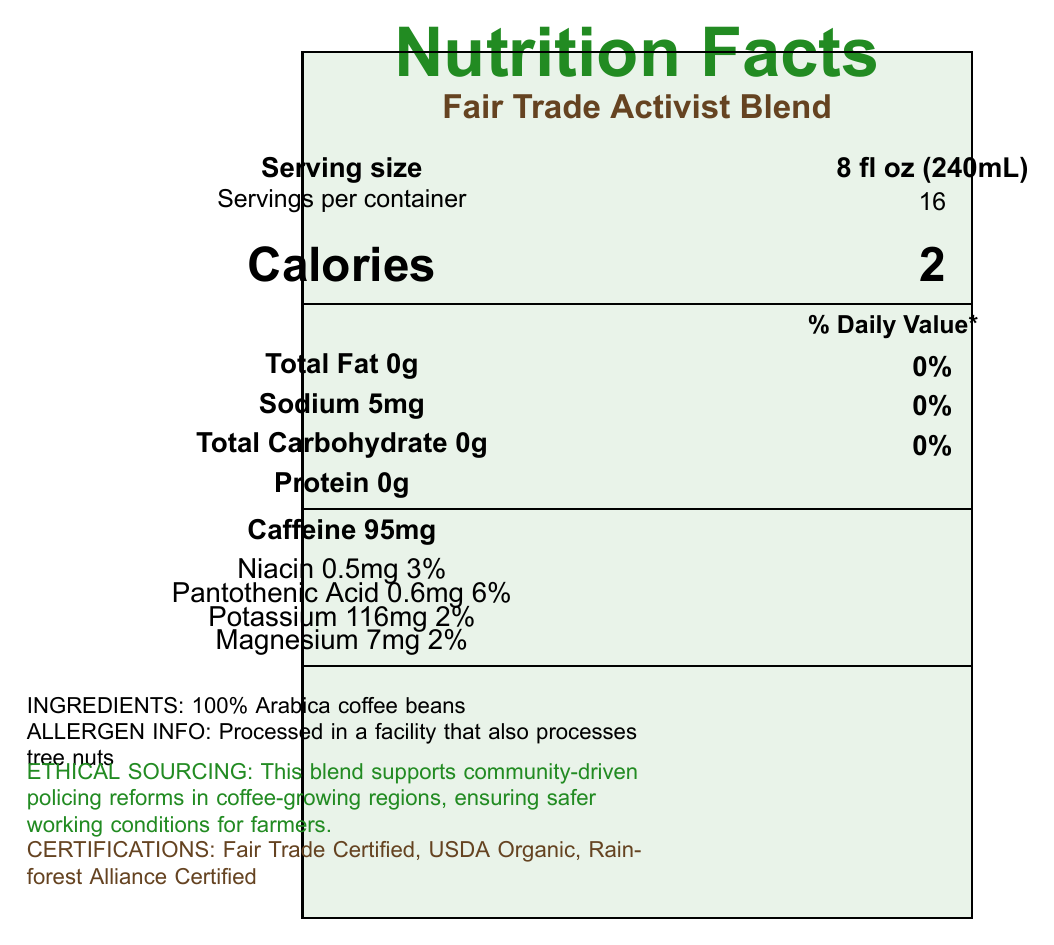what is the product name? The product name is clearly stated at the top of the document.
Answer: Fair Trade Activist Blend what is the serving size of this coffee blend? The serving size is specified below the product name and title "Serving size".
Answer: 8 fl oz (240mL) how many calories are there per serving? The number of calories per serving is shown in large font under the title "Calories".
Answer: 2 how much sodium is there per serving? The sodium content per serving is listed under "Nutrient information" in the document.
Answer: 5mg what is the amount of caffeine per serving? The amount of caffeine per serving is listed separately under "Nutrient information".
Answer: 95mg which vitamins and minerals are included in this coffee blend, and their corresponding daily values? The vitamins and minerals along with their daily values are listed under the nutrient information section.
Answer: Niacin 3%, Pantothenic Acid 6%, Potassium 2%, Magnesium 2% what ingredient is used in this coffee blend? The ingredient list specifies "100% Arabica coffee beans".
Answer: 100% Arabica coffee beans what is the allergen information for this product? The allergen information is stated at the bottom of the document.
Answer: Processed in a facility that also processes tree nuts how many servings are there per container? The number of servings per container is listed under "Serving size information".
Answer: 16 what are the ethical sourcing practices mentioned for this coffee blend? The ethical sourcing statement is highlighted in green and is clearly visible.
Answer: Supports community-driven policing reforms in coffee-growing regions, ensuring safer working conditions for farmers. which certifications does this coffee blend have? A. Fair Trade Certified B. USDA Organic C. Rainforest Alliance Certified D. All of the above The certifications section lists all three certifications: Fair Trade Certified, USDA Organic, Rainforest Alliance Certified.
Answer: D what percentage of the daily value of Pantothenic Acid is in one serving? A. 2% B. 3% C. 6% D. 9% The percentage of the daily value of Pantothenic Acid is listed as 6% in the nutrition section.
Answer: C is this coffee blend organic? The certifications section includes "USDA Organic," indicating it is organic.
Answer: Yes summarize the main idea of the document. The document primarily focuses on nutritional information, ethical sourcing, and certifications, highlighting the product's commitment to fair trade and community support.
Answer: The document provides detailed nutrition facts for the Fair Trade Activist Blend coffee, including serving size, calories, nutrients, and ethical sourcing practices. It emphasizes the product's support for community-driven policing reforms and sustainable practices. what are the environmental benefits of this coffee blend? The environmental impact section describes the environmental benefits as being shade-grown to protect bird habitats and reduce pesticides.
Answer: Shade-grown to protect bird habitats and reduce the need for chemical pesticides where can I find detailed information about the specific farms and cooperatives? The traceability section mentions that a QR code on each bag provides detailed information about the farms and cooperatives.
Answer: Each bag features a QR code linking to detailed information about the specific farms and cooperatives. how does this blend contribute to community initiatives? The community initiatives section lists these three contributions.
Answer: Funds local oversight committees for ethical policing practices, supports farmer-led initiatives for sustainable agriculture, invests in community-based mental health services as alternatives to punitive measures. how much vitamin B12 is in this coffee blend? The document does not provide information about Vitamin B12 content.
Answer: Cannot be determined 